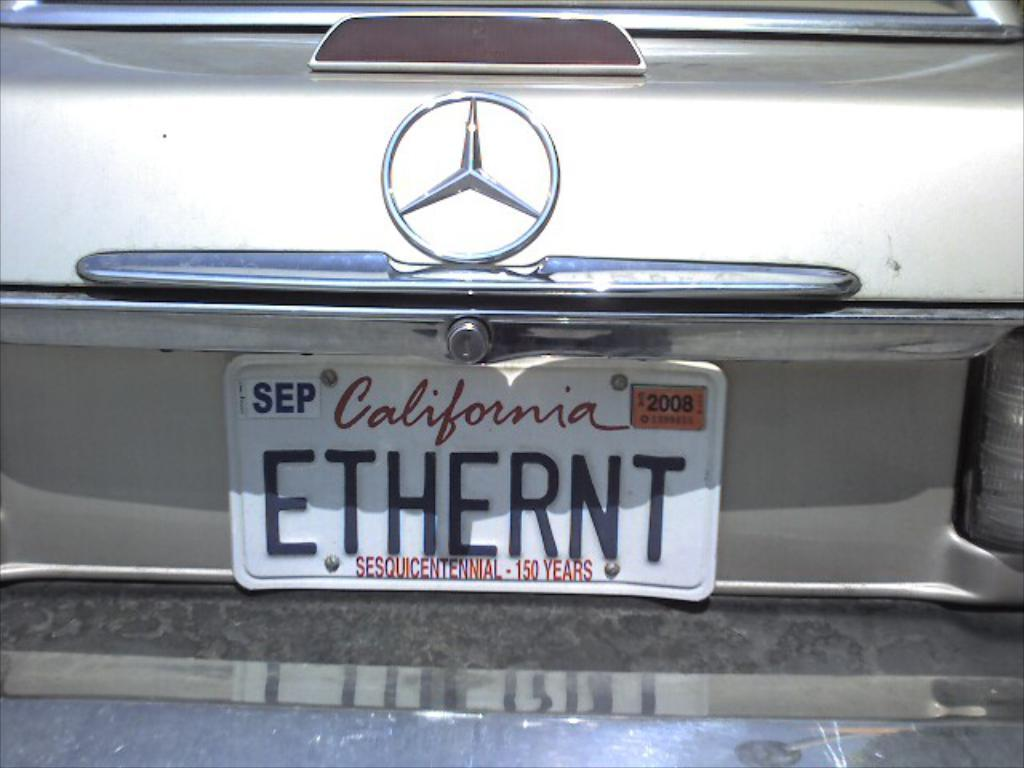<image>
Write a terse but informative summary of the picture. Virginia license plate that says ETHERNT on it. 